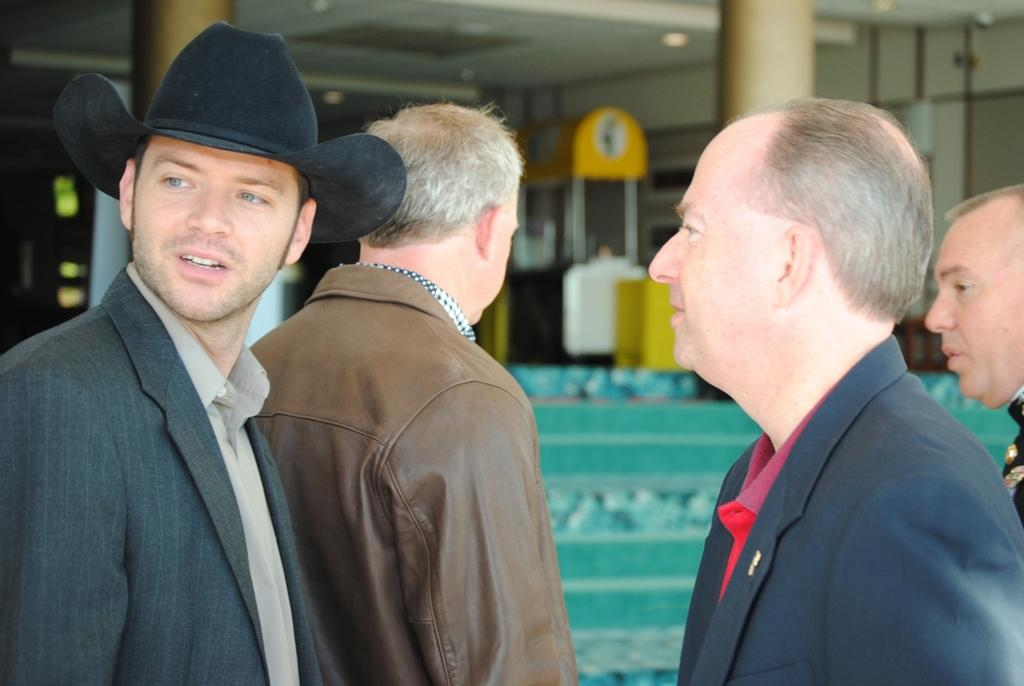What can be observed about the people in the image? There are people standing in the image. Can you describe the attire of one of the individuals? A man is wearing a suit and hat. What type of clothing are other people wearing? Other people are wearing jackets. What is visible in the background of the image? There is a food stall in the background of the image. What verse is being recited by the people in the image? There is no indication in the image that people are reciting a verse. 